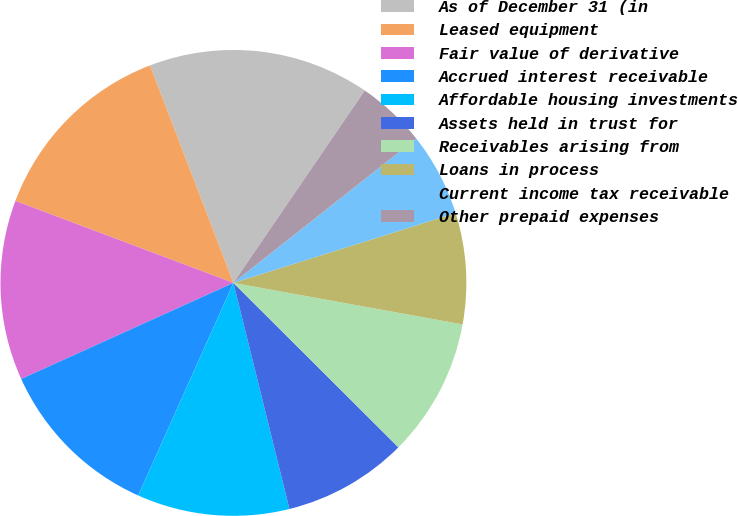Convert chart to OTSL. <chart><loc_0><loc_0><loc_500><loc_500><pie_chart><fcel>As of December 31 (in<fcel>Leased equipment<fcel>Fair value of derivative<fcel>Accrued interest receivable<fcel>Affordable housing investments<fcel>Assets held in trust for<fcel>Receivables arising from<fcel>Loans in process<fcel>Current income tax receivable<fcel>Other prepaid expenses<nl><fcel>15.36%<fcel>13.45%<fcel>12.49%<fcel>11.53%<fcel>10.57%<fcel>8.66%<fcel>9.62%<fcel>7.7%<fcel>5.79%<fcel>4.83%<nl></chart> 